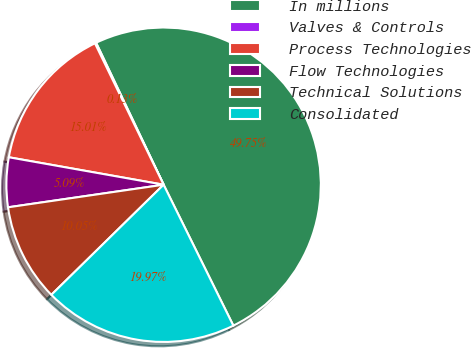Convert chart. <chart><loc_0><loc_0><loc_500><loc_500><pie_chart><fcel>In millions<fcel>Valves & Controls<fcel>Process Technologies<fcel>Flow Technologies<fcel>Technical Solutions<fcel>Consolidated<nl><fcel>49.75%<fcel>0.13%<fcel>15.01%<fcel>5.09%<fcel>10.05%<fcel>19.97%<nl></chart> 